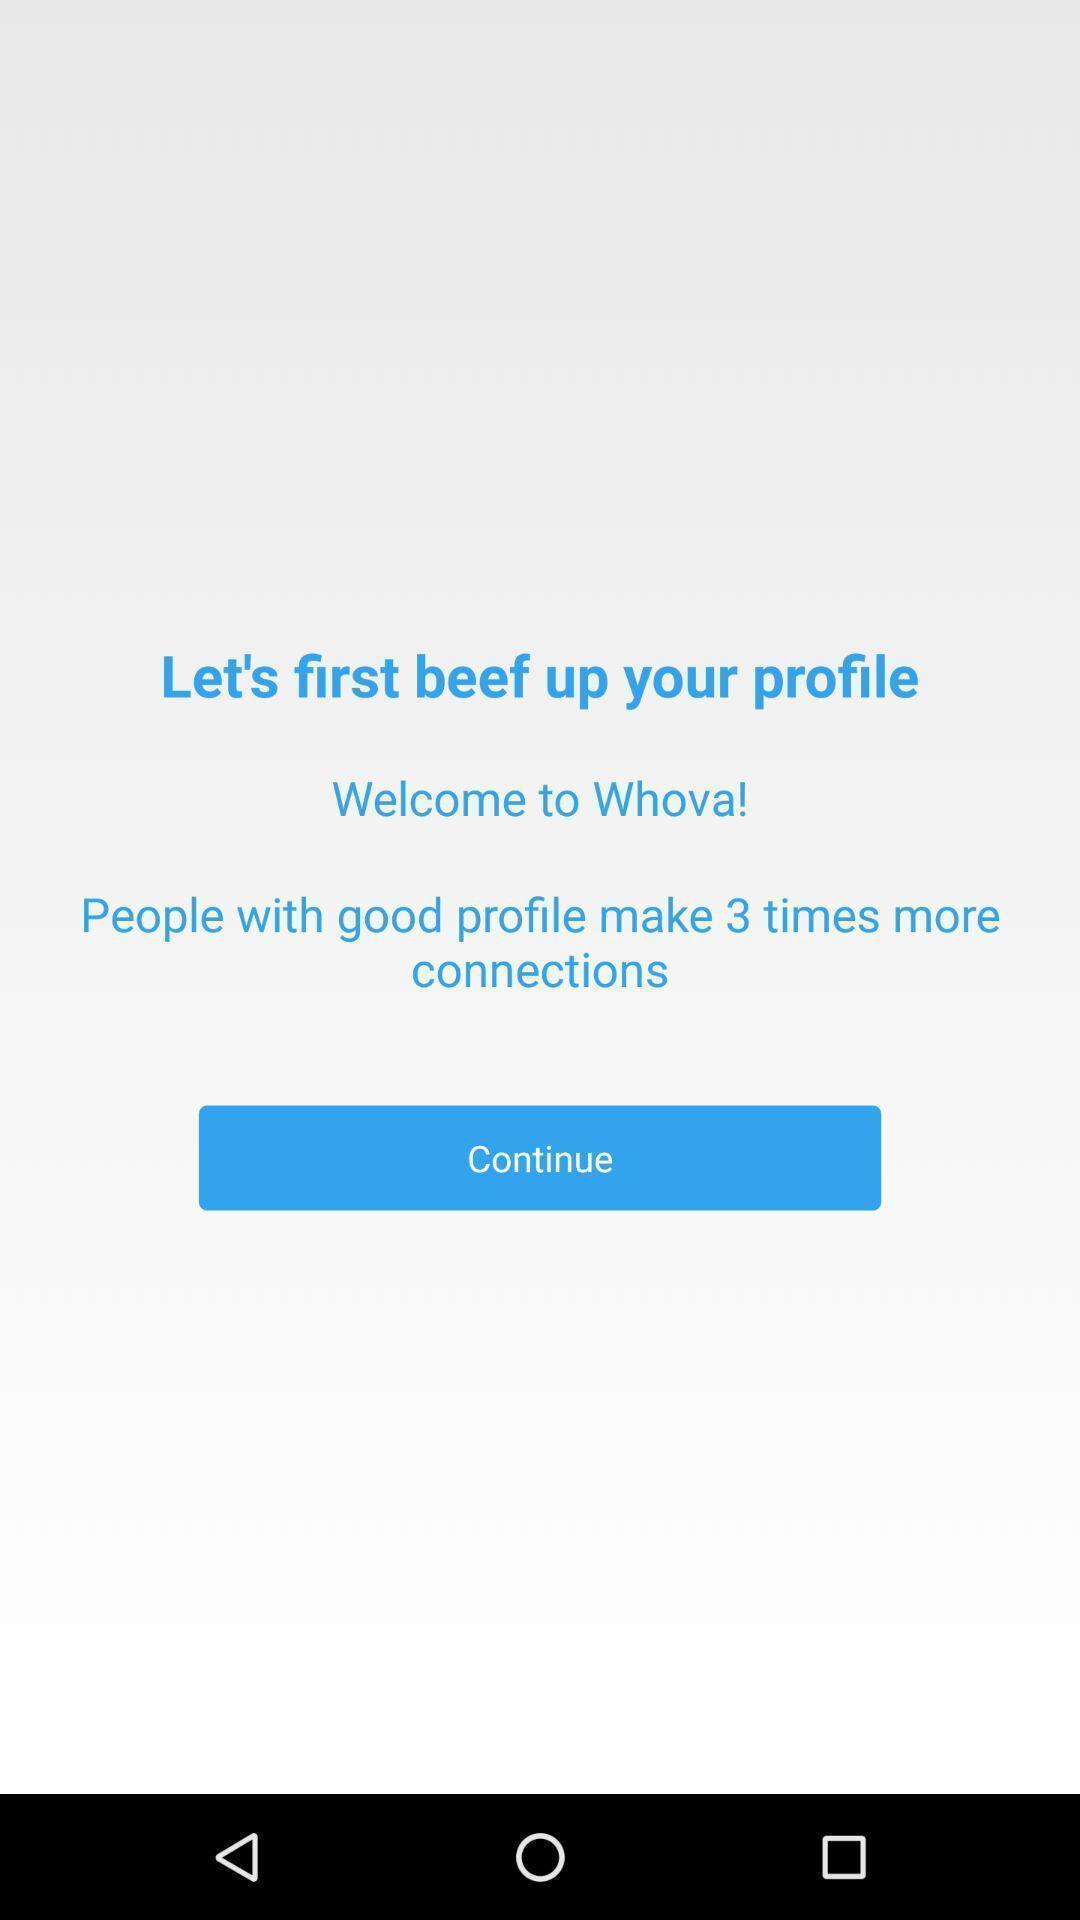What can you discern from this picture? Welcome page showing to continue the application. 